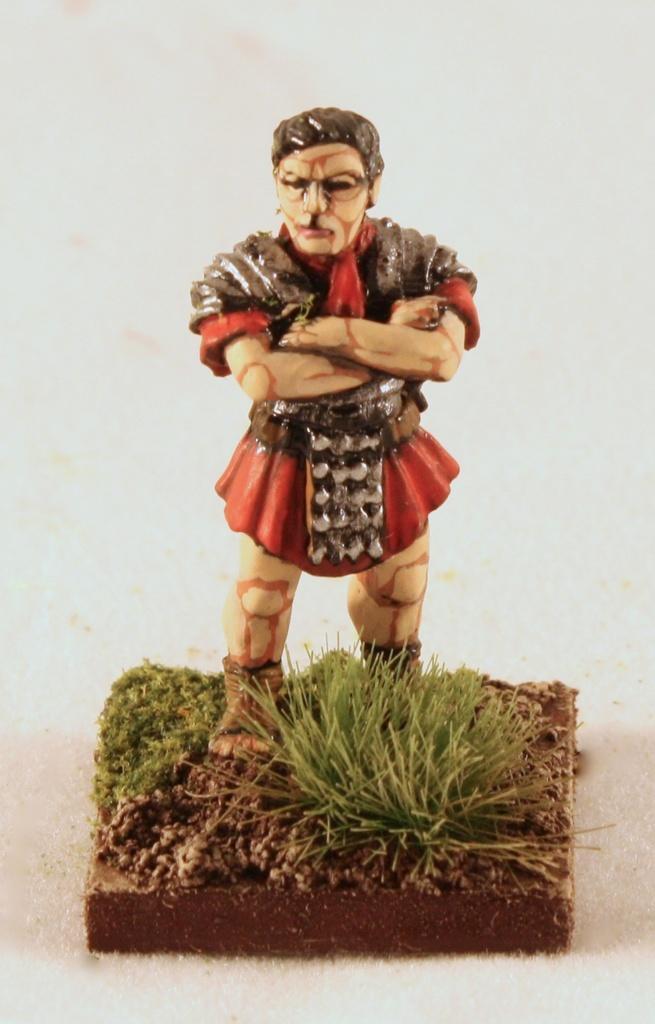Can you describe this image briefly? In the picture there is some toy and under the toy there is a grass surface in between the soil. 